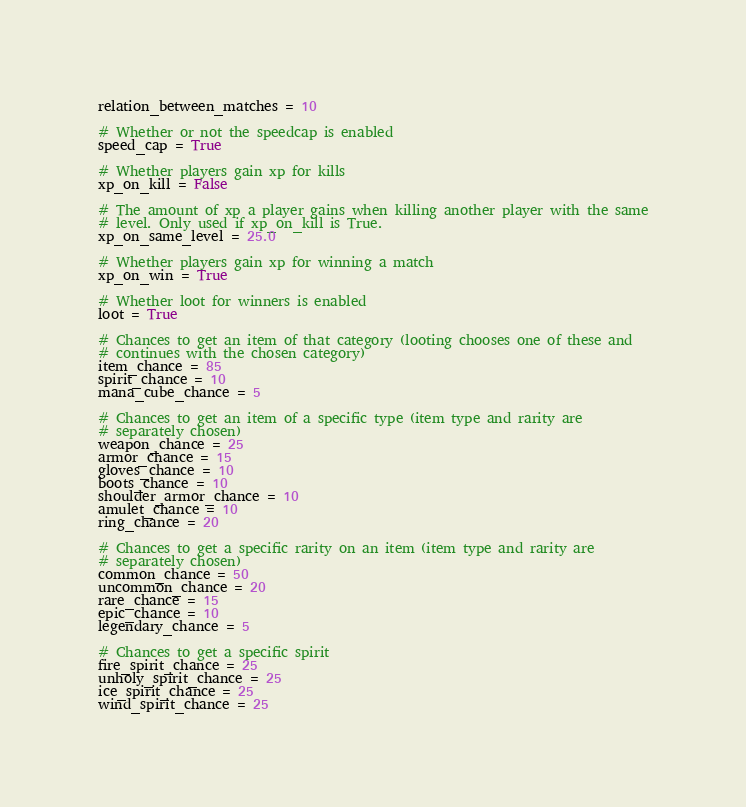<code> <loc_0><loc_0><loc_500><loc_500><_Python_>relation_between_matches = 10

# Whether or not the speedcap is enabled
speed_cap = True

# Whether players gain xp for kills
xp_on_kill = False

# The amount of xp a player gains when killing another player with the same
# level. Only used if xp_on_kill is True.
xp_on_same_level = 25.0

# Whether players gain xp for winning a match
xp_on_win = True

# Whether loot for winners is enabled
loot = True

# Chances to get an item of that category (looting chooses one of these and
# continues with the chosen category)
item_chance = 85
spirit_chance = 10
mana_cube_chance = 5

# Chances to get an item of a specific type (item type and rarity are
# separately chosen)
weapon_chance = 25
armor_chance = 15
gloves_chance = 10
boots_chance = 10
shoulder_armor_chance = 10
amulet_chance = 10
ring_chance = 20

# Chances to get a specific rarity on an item (item type and rarity are
# separately chosen)
common_chance = 50
uncommon_chance = 20
rare_chance = 15
epic_chance = 10
legendary_chance = 5

# Chances to get a specific spirit
fire_spirit_chance = 25
unholy_spirit_chance = 25
ice_spirit_chance = 25
wind_spirit_chance = 25</code> 